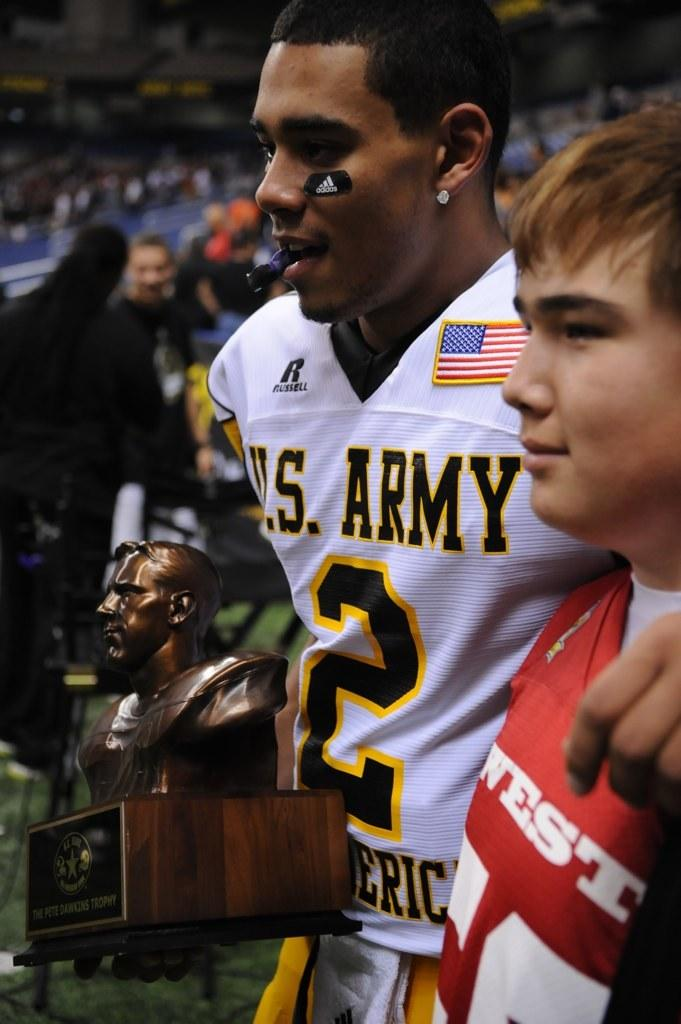<image>
Give a short and clear explanation of the subsequent image. A football player wearing the number 2 jersey is holding a trophy. 